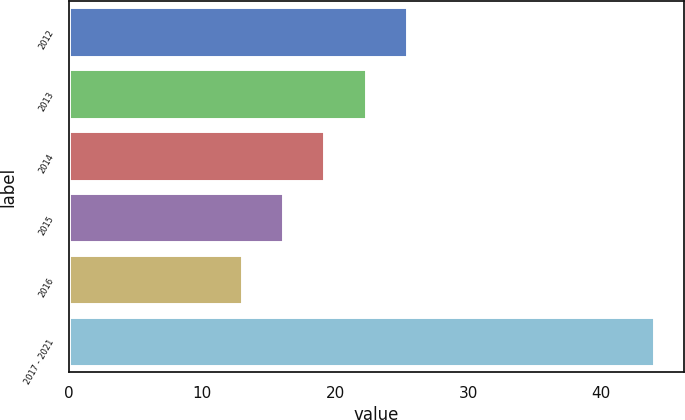Convert chart to OTSL. <chart><loc_0><loc_0><loc_500><loc_500><bar_chart><fcel>2012<fcel>2013<fcel>2014<fcel>2015<fcel>2016<fcel>2017 - 2021<nl><fcel>25.4<fcel>22.3<fcel>19.2<fcel>16.1<fcel>13<fcel>44<nl></chart> 